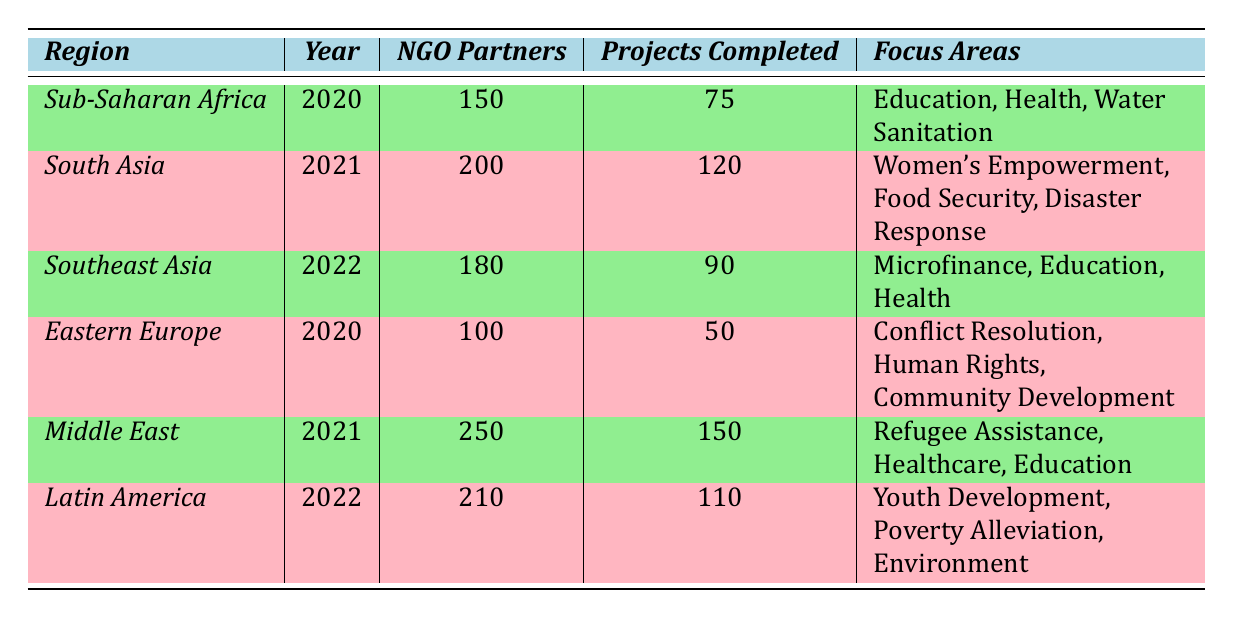What is the total number of NGO partners across all regions in 2021? The table shows that in 2021, there are NGO partners listed for South Asia (200) and Middle East (250). Summing these gives 200 + 250 = 450.
Answer: 450 Which region had the highest total funding in 2021? The table indicates that in 2021, the Middle East had total funding of 10,000,000 USD, whereas South Asia had 8,000,000 USD. Therefore, the Middle East had the highest funding.
Answer: Middle East How many projects were completed in 2020 across Sub-Saharan Africa and Eastern Europe? According to the table, Sub-Saharan Africa completed 75 projects and Eastern Europe completed 50 projects in 2020. Adding these together gives 75 + 50 = 125.
Answer: 125 Is it true that Latin America focused on Youth Development in 2022? The table lists the focus areas for Latin America in 2022 as "Youth Development, Poverty Alleviation, Environment," confirming that the statement is true.
Answer: Yes What was the difference in total funding between Southeast Asia in 2022 and Eastern Europe in 2020? The total funding for Southeast Asia in 2022 is 7,000,000 USD, and for Eastern Europe in 2020 it is 3,000,000 USD. The difference is calculated as 7,000,000 - 3,000,000 = 4,000,000 USD.
Answer: 4,000,000 USD What is the average number of projects completed across all regions for the year 2022? The completed projects for 2022 are: Southeast Asia (90) and Latin America (110). Summing these gives 90 + 110 = 200. There are 2 entries for 2022, so the average is 200 / 2 = 100.
Answer: 100 Which focus area is common between Sub-Saharan Africa and Southeast Asia? The focus areas for Sub-Saharan Africa are Education, Health, Water Sanitation, while Southeast Asia has Microfinance, Education, and Health. The common area is "Health."
Answer: Health What year saw the largest number of projects completed, and how many projects were completed? Looking at the table, in 2021 the Middle East completed the most projects at 150, which is greater than other regions’ project completions for other years.
Answer: 2021, 150 projects How much total funding was provided in Latin America in comparison to Sub-Saharan Africa? Latin America received 6,200,000 USD in 2022, while Sub-Saharan Africa received 5,000,000 USD in 2020. Comparing these, Latin America's funding is greater: 6,200,000 - 5,000,000 = 1,200,000 USD more.
Answer: 1,200,000 USD more What was the total number of NGO partners in the regions for 2020? The total number of NGO partners in 2020 includes Sub-Saharan Africa (150) and Eastern Europe (100). Adding these gives 150 + 100 = 250.
Answer: 250 